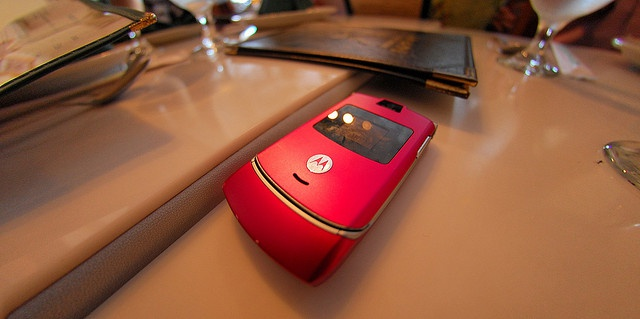Describe the objects in this image and their specific colors. I can see dining table in tan, salmon, brown, and maroon tones, cell phone in tan, brown, red, maroon, and salmon tones, book in tan, gray, black, and maroon tones, wine glass in tan, gray, brown, and darkgray tones, and wine glass in tan, gray, darkgray, and brown tones in this image. 